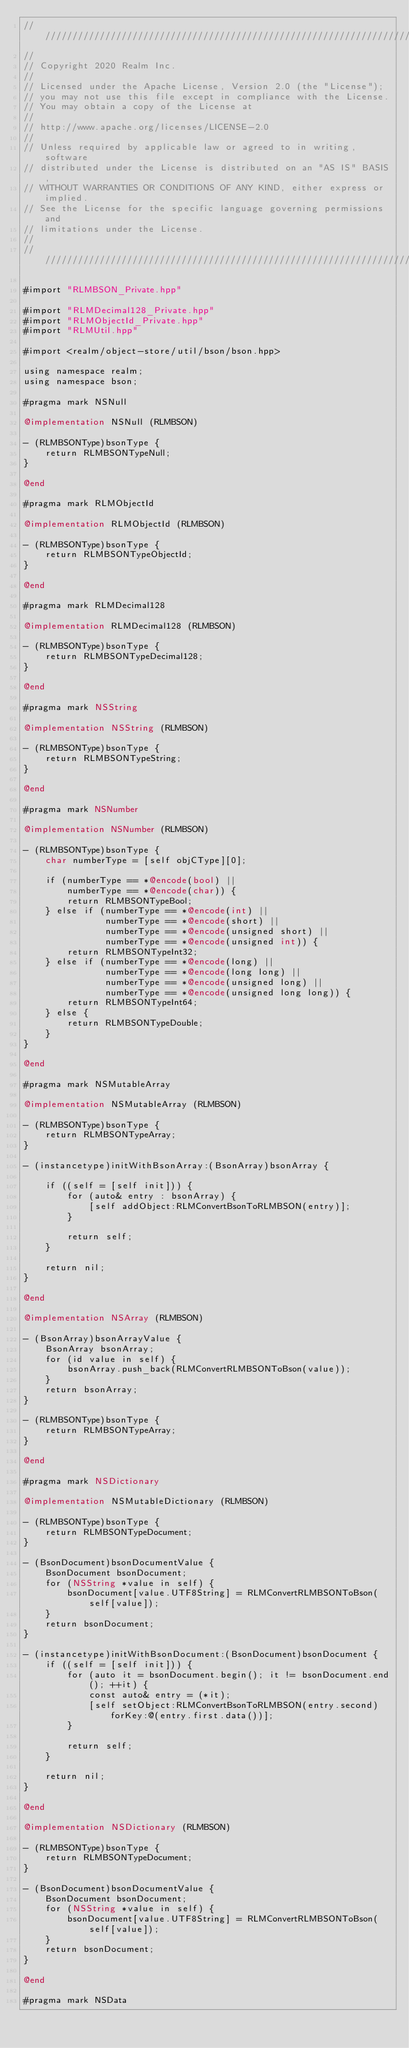Convert code to text. <code><loc_0><loc_0><loc_500><loc_500><_ObjectiveC_>////////////////////////////////////////////////////////////////////////////
//
// Copyright 2020 Realm Inc.
//
// Licensed under the Apache License, Version 2.0 (the "License");
// you may not use this file except in compliance with the License.
// You may obtain a copy of the License at
//
// http://www.apache.org/licenses/LICENSE-2.0
//
// Unless required by applicable law or agreed to in writing, software
// distributed under the License is distributed on an "AS IS" BASIS,
// WITHOUT WARRANTIES OR CONDITIONS OF ANY KIND, either express or implied.
// See the License for the specific language governing permissions and
// limitations under the License.
//
////////////////////////////////////////////////////////////////////////////

#import "RLMBSON_Private.hpp"

#import "RLMDecimal128_Private.hpp"
#import "RLMObjectId_Private.hpp"
#import "RLMUtil.hpp"

#import <realm/object-store/util/bson/bson.hpp>

using namespace realm;
using namespace bson;

#pragma mark NSNull

@implementation NSNull (RLMBSON)

- (RLMBSONType)bsonType {
    return RLMBSONTypeNull;
}

@end

#pragma mark RLMObjectId

@implementation RLMObjectId (RLMBSON)

- (RLMBSONType)bsonType {
    return RLMBSONTypeObjectId;
}

@end

#pragma mark RLMDecimal128

@implementation RLMDecimal128 (RLMBSON)

- (RLMBSONType)bsonType {
    return RLMBSONTypeDecimal128;
}

@end

#pragma mark NSString

@implementation NSString (RLMBSON)

- (RLMBSONType)bsonType {
    return RLMBSONTypeString;
}

@end

#pragma mark NSNumber

@implementation NSNumber (RLMBSON)

- (RLMBSONType)bsonType {
    char numberType = [self objCType][0];
    
    if (numberType == *@encode(bool) ||
        numberType == *@encode(char)) {
        return RLMBSONTypeBool;
    } else if (numberType == *@encode(int) ||
               numberType == *@encode(short) ||
               numberType == *@encode(unsigned short) ||
               numberType == *@encode(unsigned int)) {
        return RLMBSONTypeInt32;
    } else if (numberType == *@encode(long) ||
               numberType == *@encode(long long) ||
               numberType == *@encode(unsigned long) ||
               numberType == *@encode(unsigned long long)) {
        return RLMBSONTypeInt64;
    } else {
        return RLMBSONTypeDouble;
    }
}

@end

#pragma mark NSMutableArray

@implementation NSMutableArray (RLMBSON)

- (RLMBSONType)bsonType {
    return RLMBSONTypeArray;
}

- (instancetype)initWithBsonArray:(BsonArray)bsonArray {

    if ((self = [self init])) {
        for (auto& entry : bsonArray) {
            [self addObject:RLMConvertBsonToRLMBSON(entry)];
        }

        return self;
    }

    return nil;
}

@end

@implementation NSArray (RLMBSON)

- (BsonArray)bsonArrayValue {
    BsonArray bsonArray;
    for (id value in self) {
        bsonArray.push_back(RLMConvertRLMBSONToBson(value));
    }
    return bsonArray;
}

- (RLMBSONType)bsonType {
    return RLMBSONTypeArray;
}

@end

#pragma mark NSDictionary

@implementation NSMutableDictionary (RLMBSON)

- (RLMBSONType)bsonType {
    return RLMBSONTypeDocument;
}

- (BsonDocument)bsonDocumentValue {
    BsonDocument bsonDocument;
    for (NSString *value in self) {
        bsonDocument[value.UTF8String] = RLMConvertRLMBSONToBson(self[value]);
    }
    return bsonDocument;
}

- (instancetype)initWithBsonDocument:(BsonDocument)bsonDocument {
    if ((self = [self init])) {
        for (auto it = bsonDocument.begin(); it != bsonDocument.end(); ++it) {
            const auto& entry = (*it);
            [self setObject:RLMConvertBsonToRLMBSON(entry.second) forKey:@(entry.first.data())];
        }

        return self;
    }

    return nil;
}

@end

@implementation NSDictionary (RLMBSON)

- (RLMBSONType)bsonType {
    return RLMBSONTypeDocument;
}

- (BsonDocument)bsonDocumentValue {
    BsonDocument bsonDocument;
    for (NSString *value in self) {
        bsonDocument[value.UTF8String] = RLMConvertRLMBSONToBson(self[value]);
    }
    return bsonDocument;
}

@end

#pragma mark NSData
</code> 